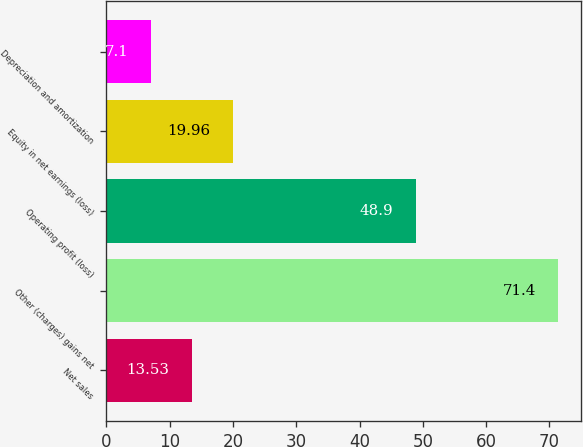Convert chart to OTSL. <chart><loc_0><loc_0><loc_500><loc_500><bar_chart><fcel>Net sales<fcel>Other (charges) gains net<fcel>Operating profit (loss)<fcel>Equity in net earnings (loss)<fcel>Depreciation and amortization<nl><fcel>13.53<fcel>71.4<fcel>48.9<fcel>19.96<fcel>7.1<nl></chart> 